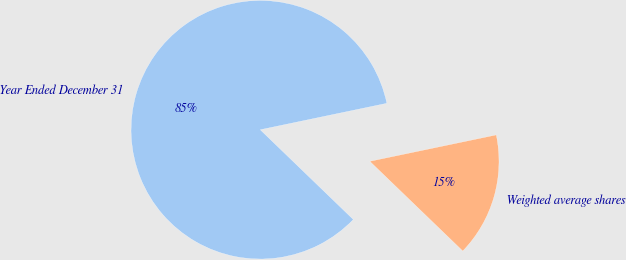Convert chart to OTSL. <chart><loc_0><loc_0><loc_500><loc_500><pie_chart><fcel>Year Ended December 31<fcel>Weighted average shares<nl><fcel>84.51%<fcel>15.49%<nl></chart> 